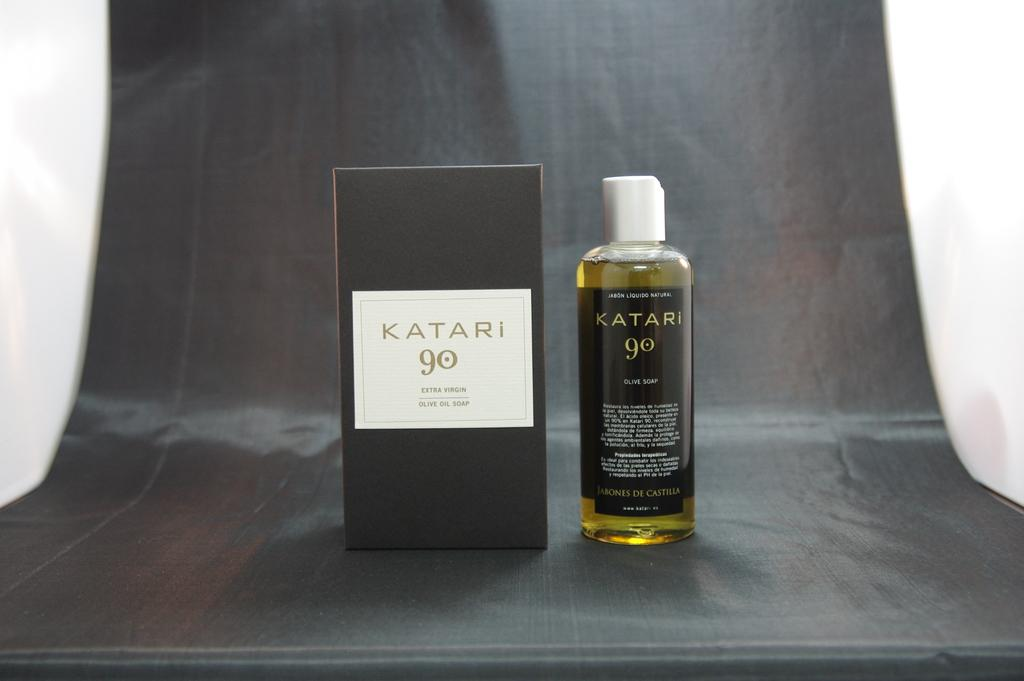<image>
Summarize the visual content of the image. A box of Katari extra virgin olive oil soap is next to a Katari bottle. 